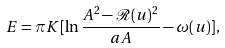Convert formula to latex. <formula><loc_0><loc_0><loc_500><loc_500>E = \pi K [ \ln \frac { A ^ { 2 } - \mathcal { R } ( u ) ^ { 2 } } { a A } - \omega ( u ) ] ,</formula> 